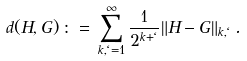<formula> <loc_0><loc_0><loc_500><loc_500>d ( H , G ) \, \colon = \, \sum _ { k , \ell = 1 } ^ { \infty } \frac { 1 } { 2 ^ { k + \ell } } \| H - G \| _ { k , \ell } \, .</formula> 